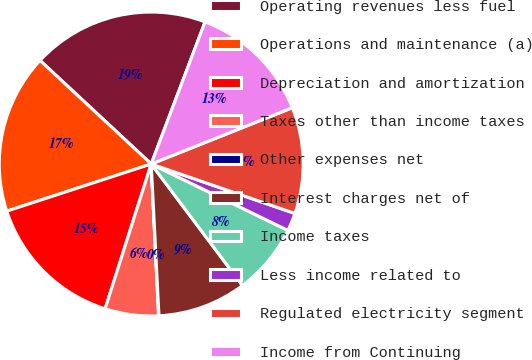<chart> <loc_0><loc_0><loc_500><loc_500><pie_chart><fcel>Operating revenues less fuel<fcel>Operations and maintenance (a)<fcel>Depreciation and amortization<fcel>Taxes other than income taxes<fcel>Other expenses net<fcel>Interest charges net of<fcel>Income taxes<fcel>Less income related to<fcel>Regulated electricity segment<fcel>Income from Continuing<nl><fcel>18.84%<fcel>16.96%<fcel>15.08%<fcel>5.68%<fcel>0.04%<fcel>9.44%<fcel>7.56%<fcel>1.92%<fcel>11.32%<fcel>13.2%<nl></chart> 